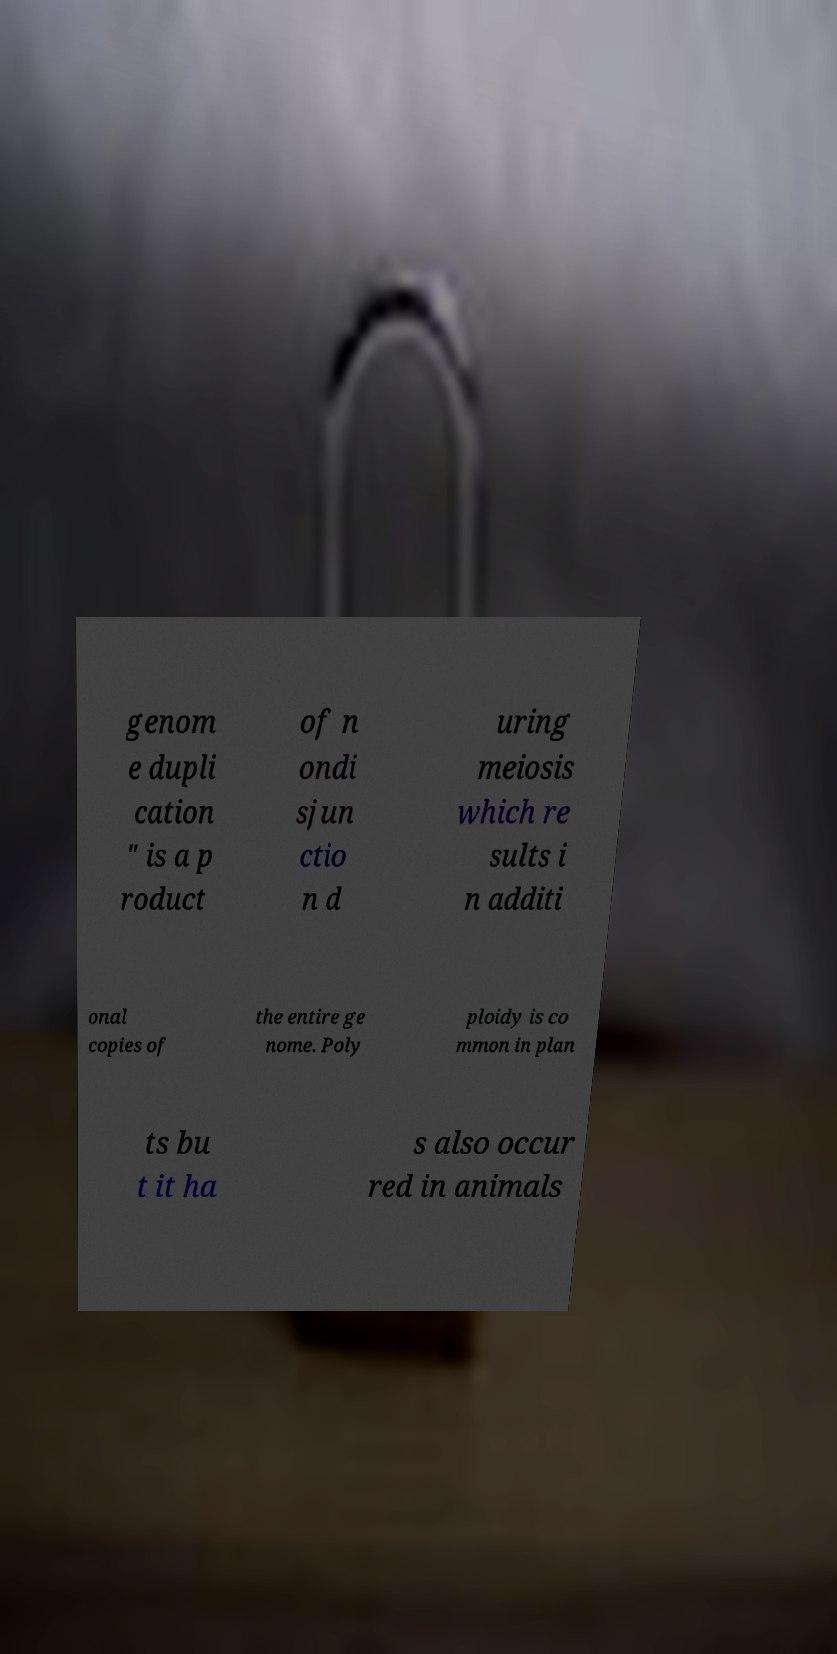There's text embedded in this image that I need extracted. Can you transcribe it verbatim? genom e dupli cation " is a p roduct of n ondi sjun ctio n d uring meiosis which re sults i n additi onal copies of the entire ge nome. Poly ploidy is co mmon in plan ts bu t it ha s also occur red in animals 